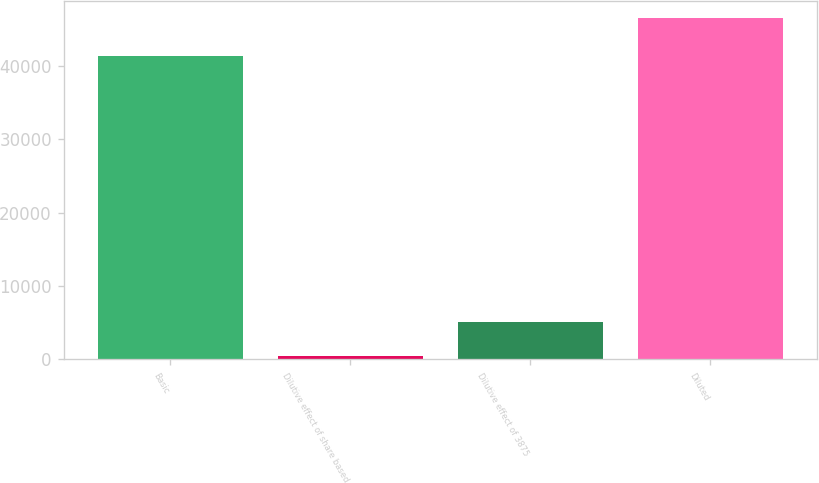Convert chart to OTSL. <chart><loc_0><loc_0><loc_500><loc_500><bar_chart><fcel>Basic<fcel>Dilutive effect of share based<fcel>Dilutive effect of 3875<fcel>Diluted<nl><fcel>41366<fcel>450<fcel>5052<fcel>46470<nl></chart> 